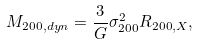Convert formula to latex. <formula><loc_0><loc_0><loc_500><loc_500>M _ { 2 0 0 , d y n } = \frac { 3 } { G } \sigma _ { 2 0 0 } ^ { 2 } R _ { 2 0 0 , X } ,</formula> 